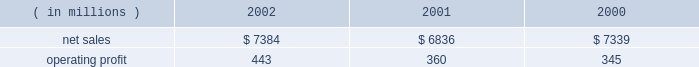Lockheed martin corporation management 2019s discussion and analysis of financial condition and results of operations december 31 , 2002 space systems space systems 2019 operating results included the following : ( in millions ) 2002 2001 2000 .
Net sales for space systems increased by 8% ( 8 % ) in 2002 compared to 2001 .
The increase in sales for 2002 resulted from higher volume in government space of $ 370 million and commercial space of $ 180 million .
In government space , increases of $ 470 million in government satellite programs and $ 130 million in ground systems activities more than offset volume declines of $ 175 million on government launch vehi- cles and $ 55 million on strategic missile programs .
The increase in commercial space sales is primarily attributable to an increase in launch vehicle activities , with nine commercial launches during 2002 compared to six in 2001 .
Net sales for the segment decreased by 7% ( 7 % ) in 2001 com- pared to 2000 .
The decrease in sales for 2001 resulted from volume declines in commercial space of $ 560 million , which more than offset increases in government space of $ 60 million .
In commercial space , sales declined due to volume reductions of $ 480 million in commercial launch vehicle activities and $ 80 million in satellite programs .
There were six launches in 2001 compared to 14 launches in 2000 .
The increase in gov- ernment space resulted from a combined increase of $ 230 mil- lion related to higher volume on government satellite programs and ground systems activities .
These increases were partially offset by a $ 110 million decrease related to volume declines in government launch vehicle activity , primarily due to program maturities , and by $ 50 million due to the absence in 2001 of favorable adjustments recorded on the titan iv pro- gram in 2000 .
Operating profit for the segment increased 23% ( 23 % ) in 2002 as compared to 2001 , mainly driven by the commercial space business .
Reduced losses in commercial space during 2002 resulted in increased operating profit of $ 90 million when compared to 2001 .
Commercial satellite manufacturing losses declined $ 100 million in 2002 as operating performance improved and satellite deliveries increased .
In the first quarter of 2001 , a $ 40 million loss provision was recorded on certain commercial satellite manufacturing contracts .
Due to the industry-wide oversupply and deterioration of pricing in the commercial launch market , financial results on commercial launch vehicles continue to be challenging .
During 2002 , this trend led to a decline in operating profit of $ 10 million on commercial launch vehicles when compared to 2001 .
This decrease was primarily due to lower profitability of $ 55 mil- lion on the three additional launches in the current year , addi- tional charges of $ 60 million ( net of a favorable contract adjustment of $ 20 million ) for market and pricing pressures and included the adverse effect of a $ 35 million adjustment for commercial launch vehicle contract settlement costs .
The 2001 results also included charges for market and pricing pressures , which reduced that year 2019s operating profit by $ 145 million .
The $ 10 million decrease in government space 2019s operating profit for the year is primarily due to the reduced volume on government launch vehicles and strategic missile programs , which combined to decrease operating profit by $ 80 million , partially offset by increases of $ 40 million in government satellite programs and $ 30 million in ground systems activities .
Operating profit for the segment increased by 4% ( 4 % ) in 2001 compared to 2000 .
Operating profit increased in 2001 due to a $ 35 million increase in government space partially offset by higher year-over-year losses of $ 20 million in commercial space .
In government space , operating profit increased due to the impact of higher volume and improved performance in ground systems and government satellite programs .
The year- to-year comparison of operating profit was not affected by the $ 50 million favorable titan iv adjustment recorded in 2000 discussed above , due to a $ 55 million charge related to a more conservative assessment of government launch vehi- cle programs that was recorded in the fourth quarter of 2000 .
In commercial space , decreased operating profit of $ 15 mil- lion on launch vehicles more than offset lower losses on satel- lite manufacturing activities .
The commercial launch vehicle operating results included $ 60 million in higher charges for market and pricing pressures when compared to 2000 .
These negative adjustments were partially offset by $ 50 million of favorable contract adjustments on certain launch vehicle con- tracts .
Commercial satellite manufacturing losses decreased slightly from 2000 and included the adverse impact of a $ 40 million loss provision recorded in the first quarter of 2001 for certain commercial satellite contracts related to schedule and technical issues. .
What was the operating margin for space systems in 2001? 
Computations: (360 / 6836)
Answer: 0.05266. 